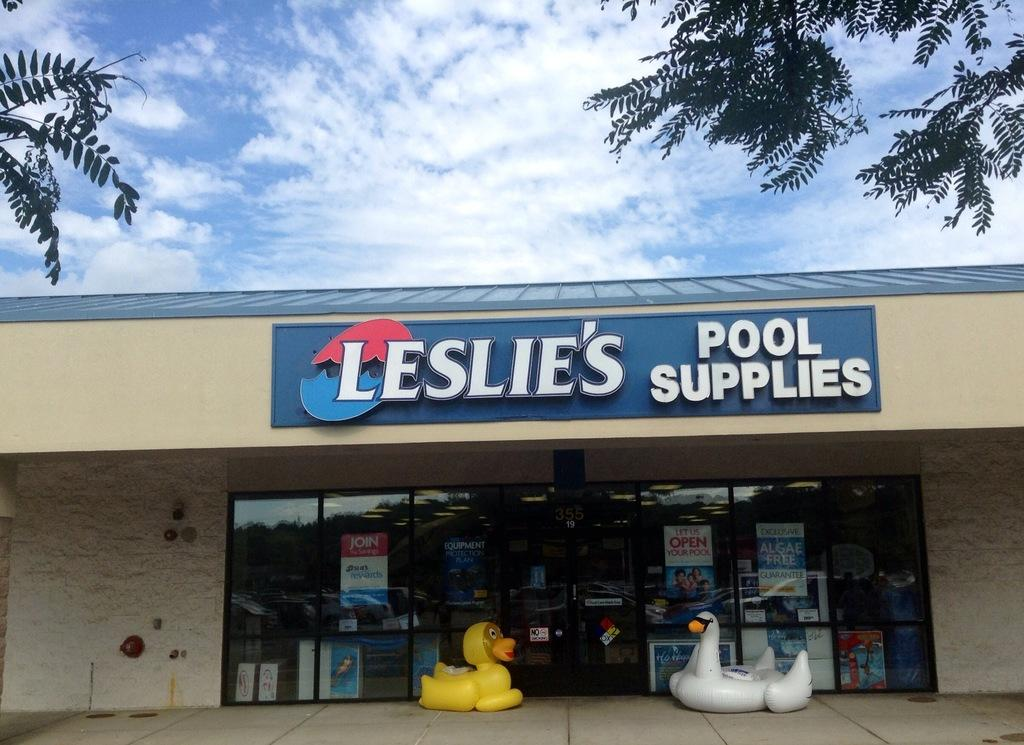What objects are on the path in the image? There are toys on the path in the image. What structure is located behind the toys in the image? There is a building behind the toys in the image. What type of vegetation is in front of the building in the image? There are trees in front of the building in the image. What is visible behind the building in the image? There is a sky visible behind the building in the image. What is the price of the police car toy in the image? There is no police car toy present in the image, so it is not possible to determine its price. 